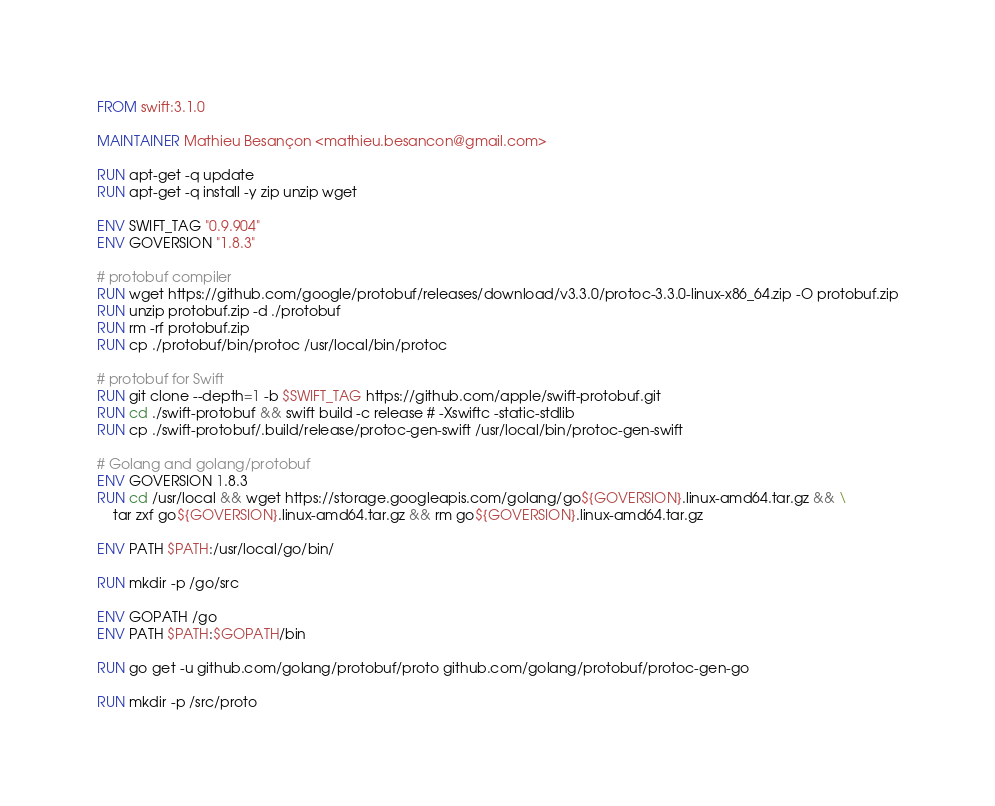<code> <loc_0><loc_0><loc_500><loc_500><_Dockerfile_>FROM swift:3.1.0

MAINTAINER Mathieu Besançon <mathieu.besancon@gmail.com>

RUN apt-get -q update
RUN apt-get -q install -y zip unzip wget

ENV SWIFT_TAG "0.9.904"
ENV GOVERSION "1.8.3"

# protobuf compiler
RUN wget https://github.com/google/protobuf/releases/download/v3.3.0/protoc-3.3.0-linux-x86_64.zip -O protobuf.zip
RUN unzip protobuf.zip -d ./protobuf
RUN rm -rf protobuf.zip
RUN cp ./protobuf/bin/protoc /usr/local/bin/protoc

# protobuf for Swift
RUN git clone --depth=1 -b $SWIFT_TAG https://github.com/apple/swift-protobuf.git
RUN cd ./swift-protobuf && swift build -c release # -Xswiftc -static-stdlib
RUN cp ./swift-protobuf/.build/release/protoc-gen-swift /usr/local/bin/protoc-gen-swift

# Golang and golang/protobuf
ENV GOVERSION 1.8.3
RUN cd /usr/local && wget https://storage.googleapis.com/golang/go${GOVERSION}.linux-amd64.tar.gz && \
    tar zxf go${GOVERSION}.linux-amd64.tar.gz && rm go${GOVERSION}.linux-amd64.tar.gz

ENV PATH $PATH:/usr/local/go/bin/

RUN mkdir -p /go/src

ENV GOPATH /go
ENV PATH $PATH:$GOPATH/bin

RUN go get -u github.com/golang/protobuf/proto github.com/golang/protobuf/protoc-gen-go

RUN mkdir -p /src/proto
</code> 